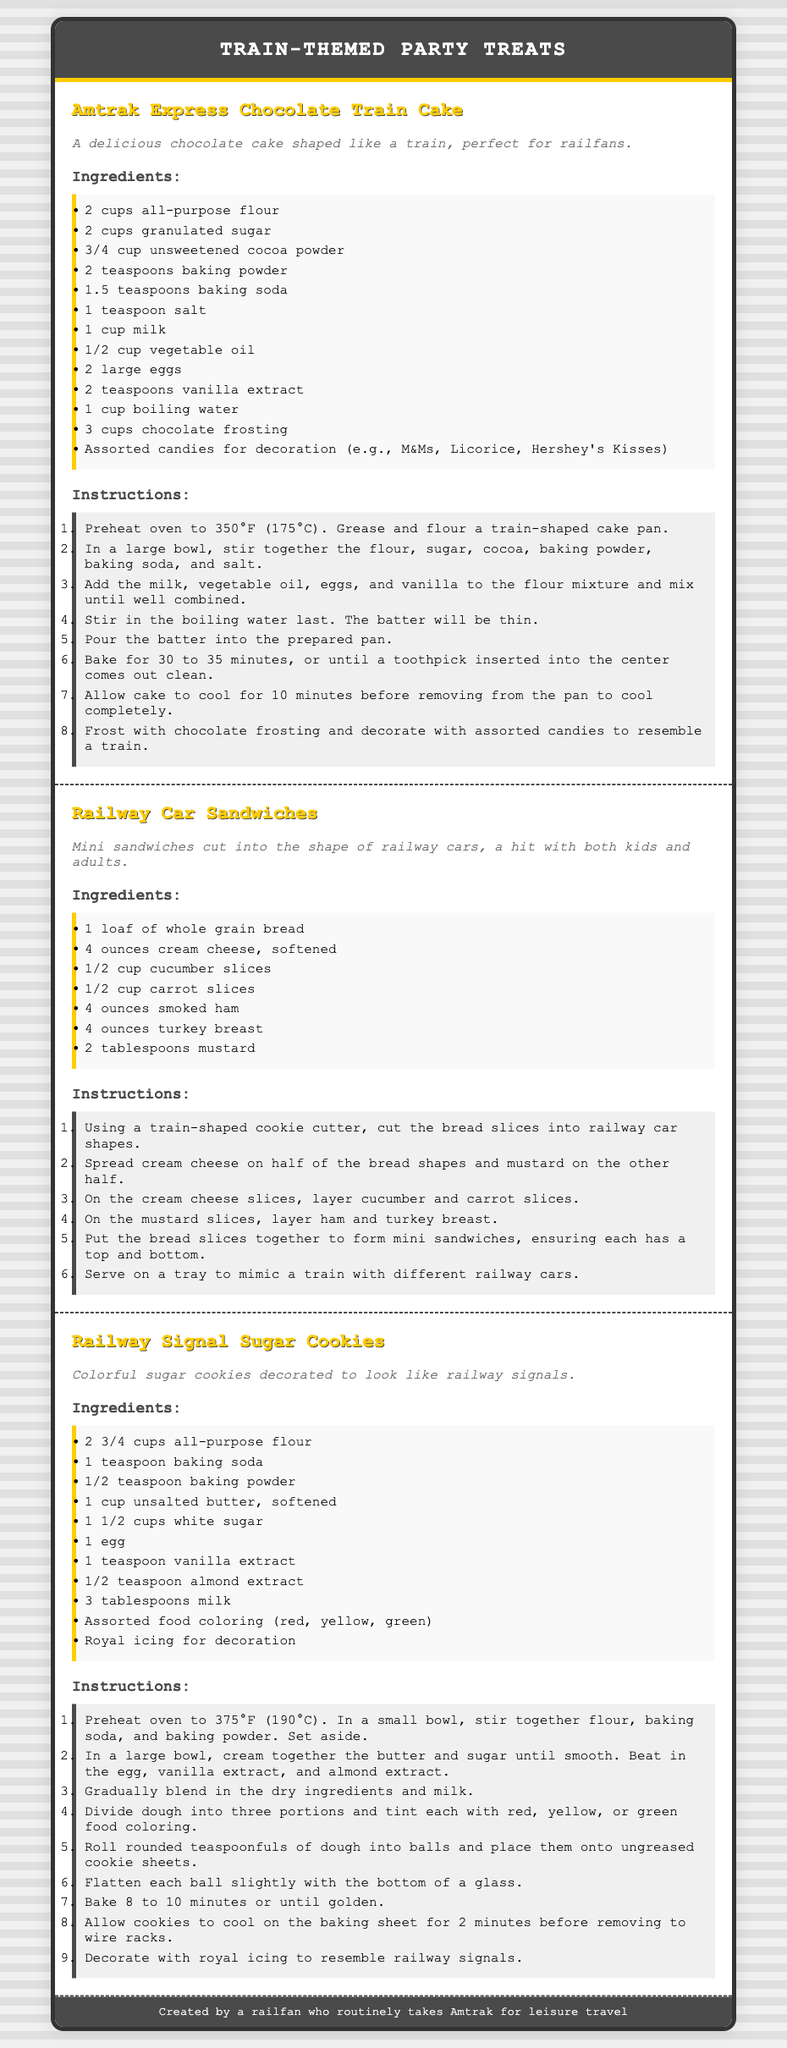what is the title of the document? The title of the document is in the header section, which indicates the main subject.
Answer: Train-Themed Party Treats how many recipes are included in the document? There are three distinct recipes provided, each with its own section.
Answer: 3 what is the main ingredient in the Amtrak Express Chocolate Train Cake? The main ingredient in many chocolate cakes is cocoa, which is listed first in the ingredients for this recipe.
Answer: cocoa powder what shape are the Railway Car Sandwiches cut into? The sandwiches are cut into shapes that resemble railway cars as specified in the recipe description.
Answer: railway cars what color are the decorations for the Railway Signal Sugar Cookies? The cookies are designed to resemble railway signals and feature primary colors for decoration.
Answer: red, yellow, green how long do you bake the Amtrak Express Chocolate Train Cake? The baking time is provided in the instructions as a specific duration.
Answer: 30 to 35 minutes what is the first step in making Railway Signal Sugar Cookies? This step is critical as it prepares the dry ingredients for the cookie dough before mixing.
Answer: Preheat oven to 375°F what type of bread is used in the Railway Car Sandwiches? The type of bread chosen impacts the healthiness and flavor of the sandwiches.
Answer: whole grain bread which ingredient combines with food coloring in the Railway Signal Sugar Cookies? The item that gets divided and colored is relevant to the cookies' final appearance.
Answer: dough 